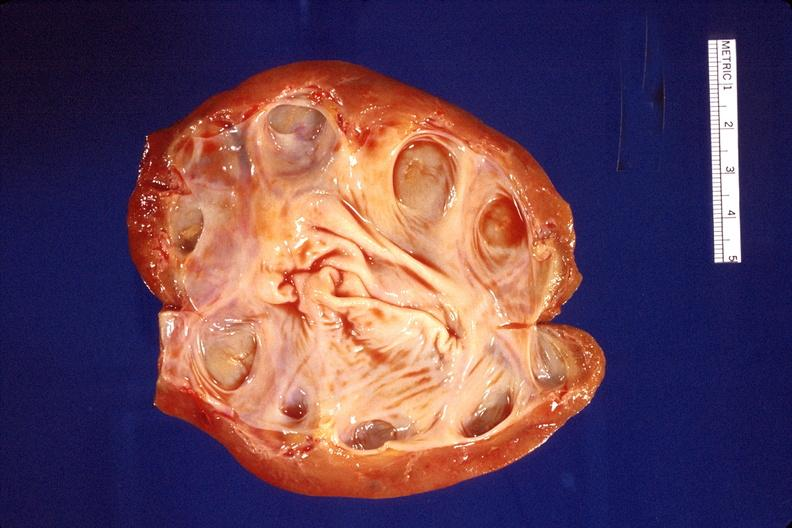does no tissue recognizable as ovary show kidney, hydronephrosis?
Answer the question using a single word or phrase. No 